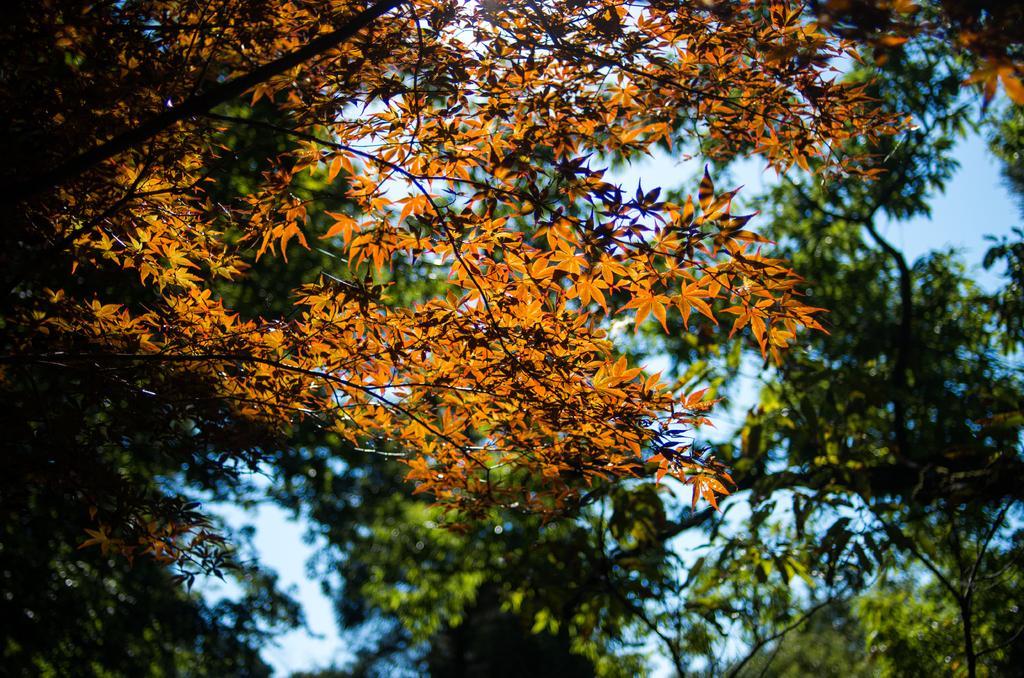How would you summarize this image in a sentence or two? In this picture I can see the trees and the sky. 